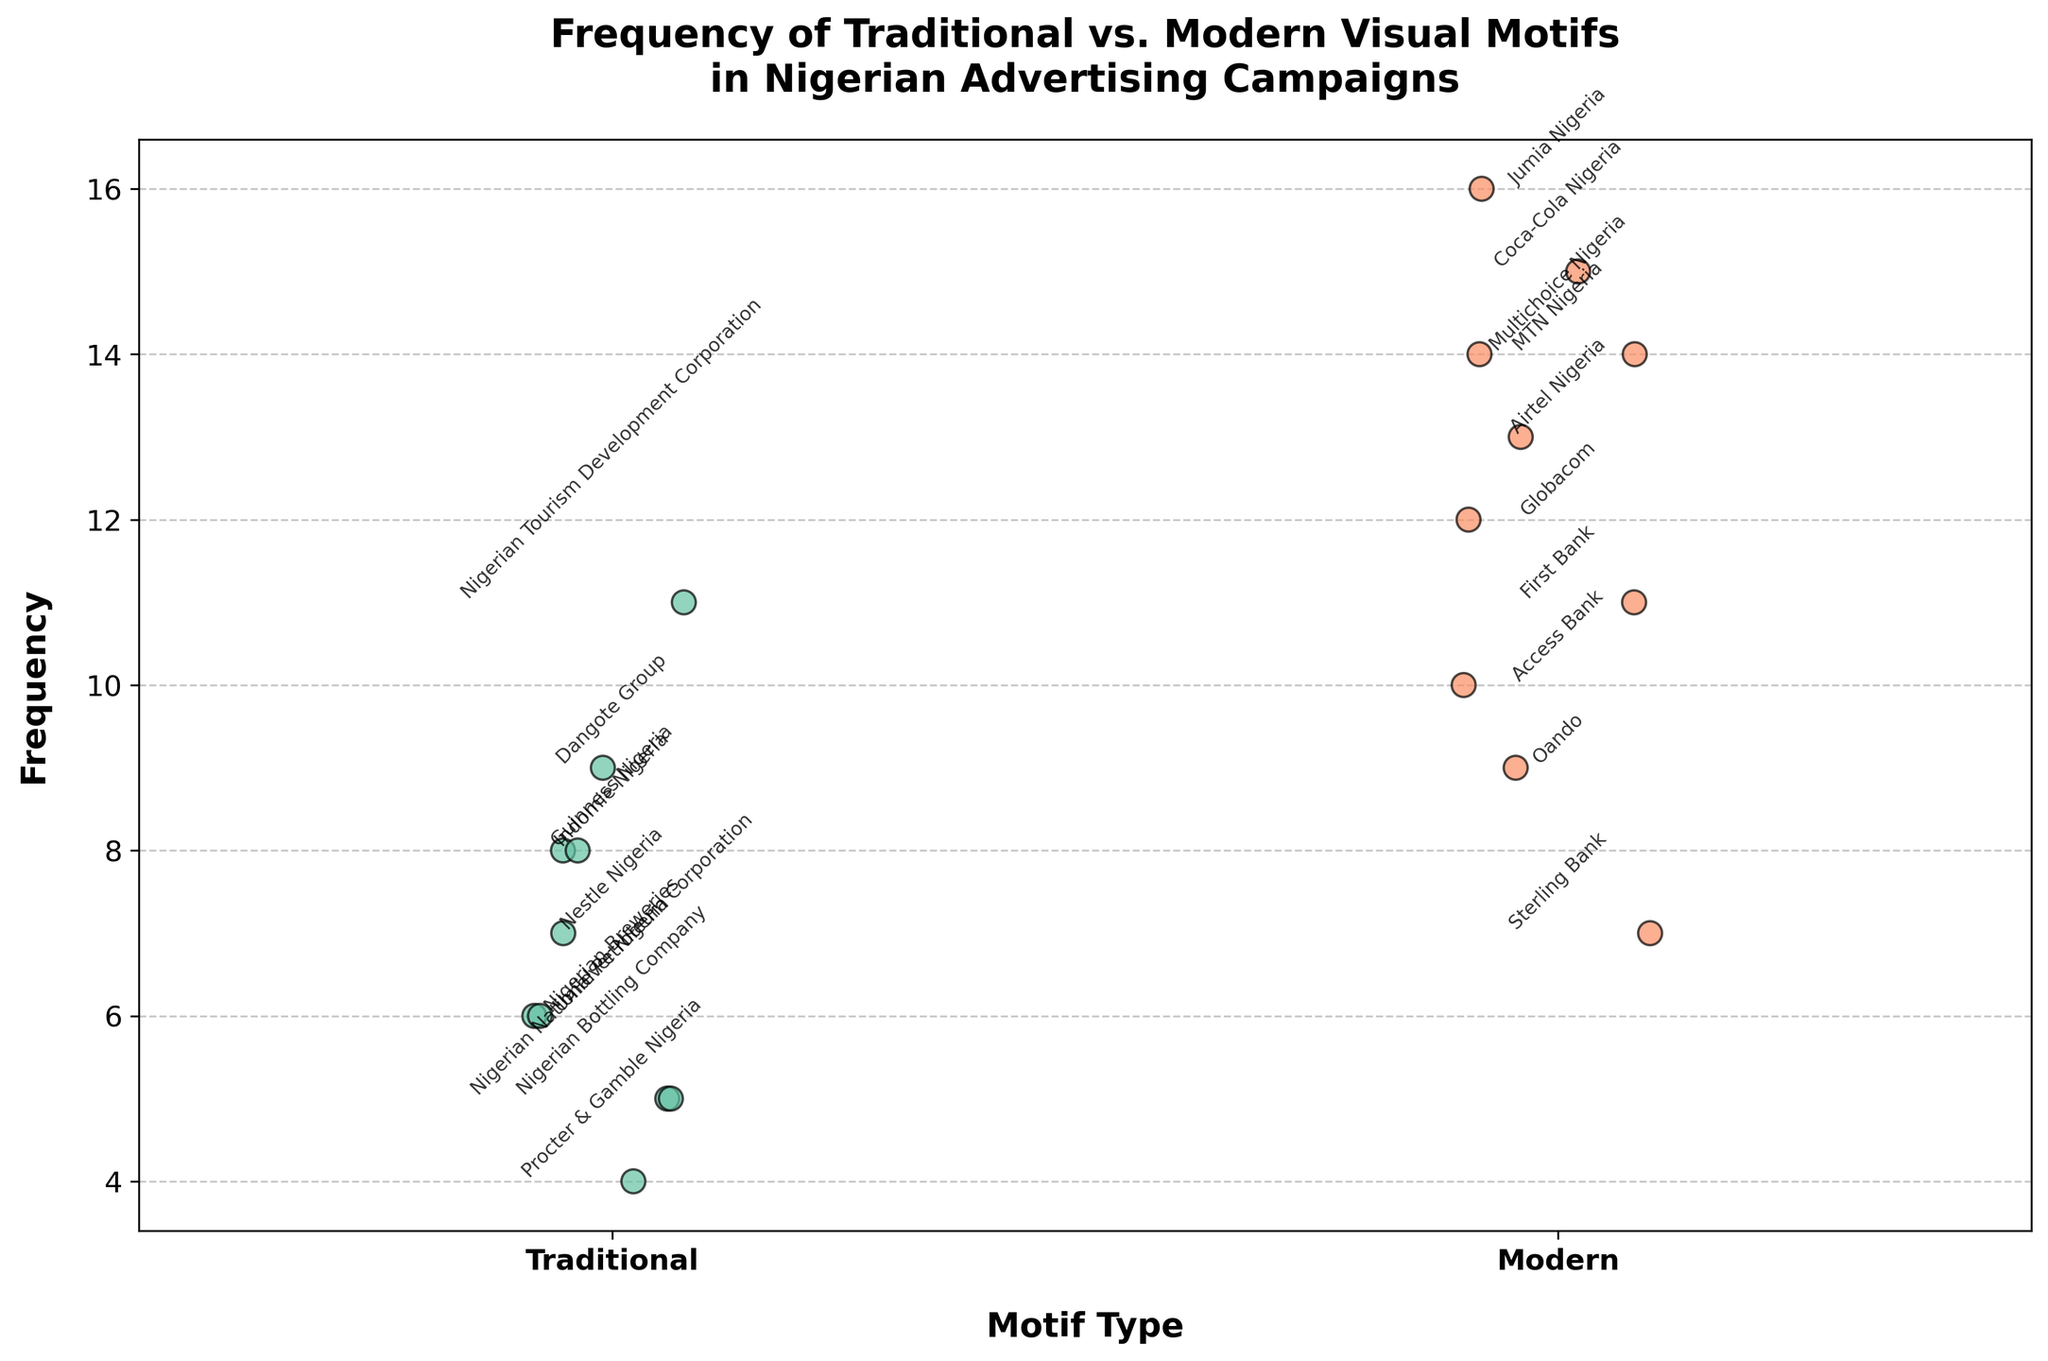What's the title of the plot? The title of the plot is displayed at the top and is usually in larger, bold font compared to other text elements.
Answer: Frequency of Traditional vs. Modern Visual Motifs in Nigerian Advertising Campaigns How many advertising campaigns used modern visual motifs? Count the number of data points (dots) under the 'Modern' category on the x-axis.
Answer: 10 Which campaign associated with traditional visual motifs has the highest frequency? Locate the highest data point in the 'Traditional' category and refer to its label.
Answer: Nigerian Tourism Development Corporation What's the range of frequencies for modern visual motifs? The range is calculated by finding the difference between the highest and lowest frequency values within the 'Modern' category. The highest frequency is 16 and the lowest is 7.
Answer: 16 - 7 = 9 What is the difference in frequency between Guinness Nigeria and Coca-Cola Nigeria? Locate the frequency of Guinness Nigeria in the 'Traditional' category (8) and the frequency of Coca-Cola Nigeria in the 'Modern' category (15) and subtract the former from the latter.
Answer: 15 - 8 = 7 Which type of motif has more variability in frequency? Compare the distribution spread of data points (dots) for each motif type. If the data points are more spread out, the variability is higher.
Answer: Modern Describe the position of Indomie Nigeria in the plot. Find the 'Traditional' category data points. Indomie Nigeria is at a frequency of 8, located slightly higher than the middle of the group in the 'Traditional' category.
Answer: Traditional category, frequency 8 What’s the average frequency of traditional visual motifs? Sum all the frequencies in the 'Traditional' category and divide by the number of data points. (8 + 6 + 9 + 7 + 5 + 6 + 4 + 8 + 11 + 5) / 10 = 69/10
Answer: 6.9 Compare the frequencies of MTN Nigeria and Globacom. Which one is higher? Locate MTN Nigeria (frequency 14) and Globacom (frequency 12) in the 'Modern' category.
Answer: MTN Nigeria How many campaigns used traditional motifs with a frequency equal to or less than 6? Count the number of data points in the 'Traditional' category with a frequency of 6 or less.
Answer: 5 